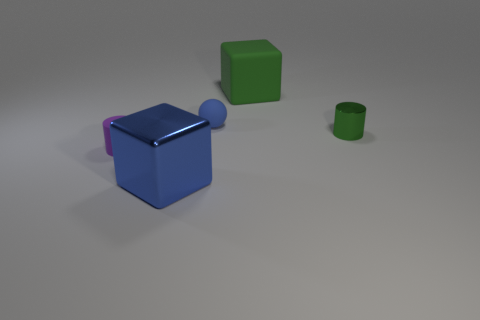How many tiny green shiny objects are the same shape as the large green matte thing?
Offer a very short reply. 0. There is a cube that is the same size as the blue metal object; what color is it?
Your answer should be compact. Green. What is the color of the large cube in front of the big thing that is to the right of the large cube in front of the big rubber block?
Your answer should be very brief. Blue. There is a green cylinder; does it have the same size as the matte thing that is left of the big blue metal block?
Ensure brevity in your answer.  Yes. What number of objects are green spheres or small cylinders?
Your response must be concise. 2. Are there any tiny green cubes that have the same material as the tiny blue ball?
Provide a succinct answer. No. There is a object that is the same color as the tiny matte sphere; what size is it?
Provide a short and direct response. Large. What is the color of the cube that is behind the big object in front of the big green cube?
Ensure brevity in your answer.  Green. Does the purple rubber cylinder have the same size as the rubber sphere?
Provide a short and direct response. Yes. What number of blocks are large matte objects or tiny green things?
Make the answer very short. 1. 